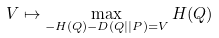Convert formula to latex. <formula><loc_0><loc_0><loc_500><loc_500>V \mapsto \max _ { - H ( Q ) - D ( Q | | P ) = V } H ( Q )</formula> 